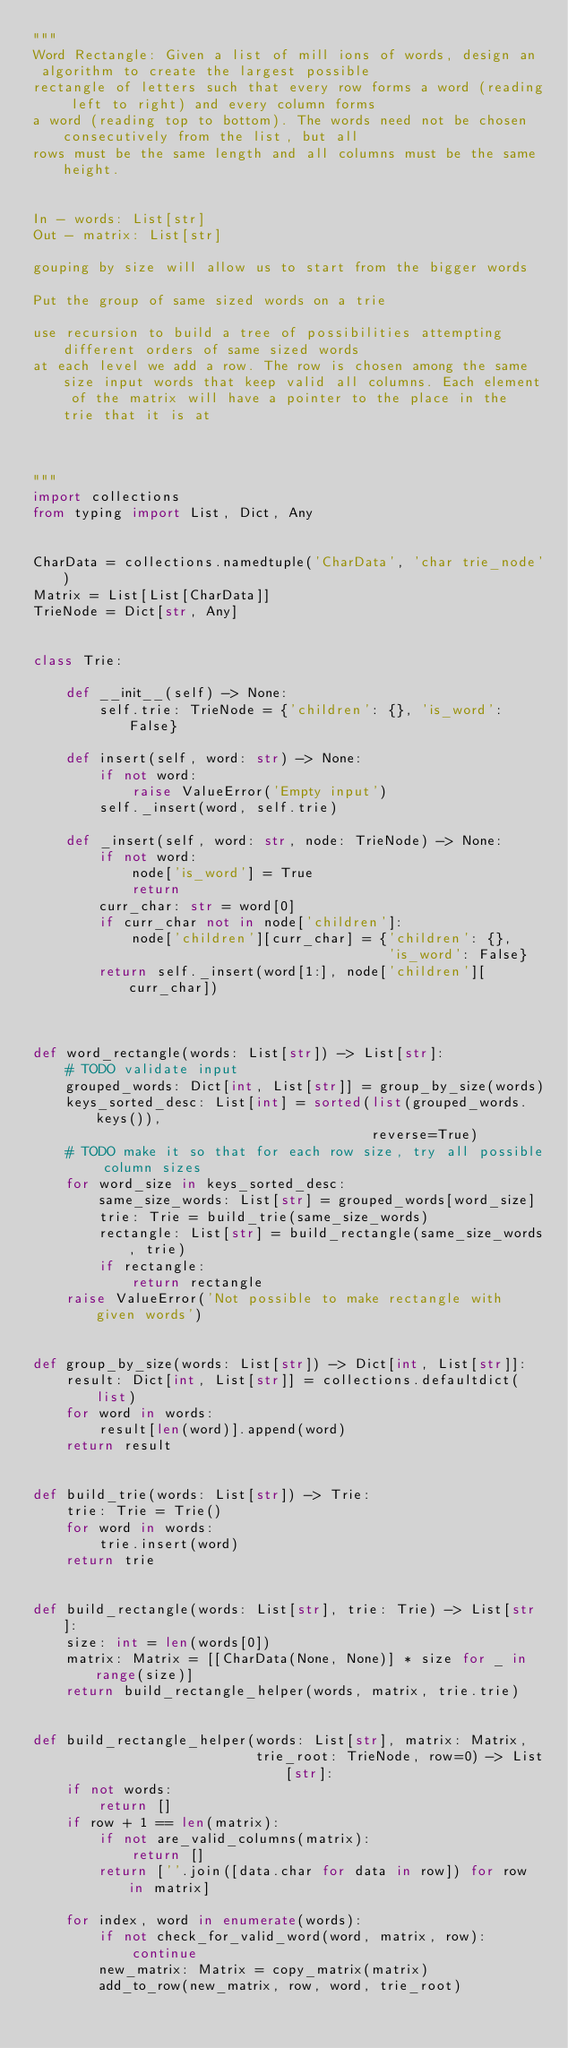<code> <loc_0><loc_0><loc_500><loc_500><_Python_>"""
Word Rectangle: Given a list of mill ions of words, design an
 algorithm to create the largest possible
rectangle of letters such that every row forms a word (reading left to right) and every column forms
a word (reading top to bottom). The words need not be chosen consecutively from the list, but all
rows must be the same length and all columns must be the same height.


In - words: List[str]
Out - matrix: List[str]

gouping by size will allow us to start from the bigger words

Put the group of same sized words on a trie

use recursion to build a tree of possibilities attempting different orders of same sized words
at each level we add a row. The row is chosen among the same size input words that keep valid all columns. Each element of the matrix will have a pointer to the place in the trie that it is at



"""
import collections
from typing import List, Dict, Any


CharData = collections.namedtuple('CharData', 'char trie_node')
Matrix = List[List[CharData]]
TrieNode = Dict[str, Any]


class Trie:
	
	def __init__(self) -> None:
		self.trie: TrieNode = {'children': {}, 'is_word': False}
	
	def insert(self, word: str) -> None:
		if not word: 
			raise ValueError('Empty input')
		self._insert(word, self.trie)

	def _insert(self, word: str, node: TrieNode) -> None:
		if not word: 
			node['is_word'] = True
			return
		curr_char: str = word[0]
		if curr_char not in node['children']: 
			node['children'][curr_char] = {'children': {}, 
										   'is_word': False}
		return self._insert(word[1:], node['children'][curr_char])



def word_rectangle(words: List[str]) -> List[str]:
	# TODO validate input
	grouped_words: Dict[int, List[str]] = group_by_size(words)
	keys_sorted_desc: List[int] = sorted(list(grouped_words.keys()), 
										 reverse=True)
	# TODO make it so that for each row size, try all possible column sizes
	for word_size in keys_sorted_desc:
		same_size_words: List[str] = grouped_words[word_size]
		trie: Trie = build_trie(same_size_words)
		rectangle: List[str] = build_rectangle(same_size_words, trie)
		if rectangle:
			return rectangle
	raise ValueError('Not possible to make rectangle with given words')


def group_by_size(words: List[str]) -> Dict[int, List[str]]:
	result: Dict[int, List[str]] = collections.defaultdict(list)
	for word in words:
		result[len(word)].append(word)
	return result


def build_trie(words: List[str]) -> Trie:
	trie: Trie = Trie()
	for word in words:
		trie.insert(word)
	return trie


def build_rectangle(words: List[str], trie: Trie) -> List[str]:
	size: int = len(words[0])
	matrix: Matrix = [[CharData(None, None)] * size	for _ in range(size)]
	return build_rectangle_helper(words, matrix, trie.trie)


def build_rectangle_helper(words: List[str], matrix: Matrix, 
						   trie_root: TrieNode, row=0) -> List[str]:
	if not words:
		return []
	if row + 1 == len(matrix):
		if not are_valid_columns(matrix):
			return []
		return [''.join([data.char for data in row]) for row in matrix]
	
	for index, word in enumerate(words):
		if not check_for_valid_word(word, matrix, row):
			continue
		new_matrix: Matrix = copy_matrix(matrix)
		add_to_row(new_matrix, row, word, trie_root)</code> 